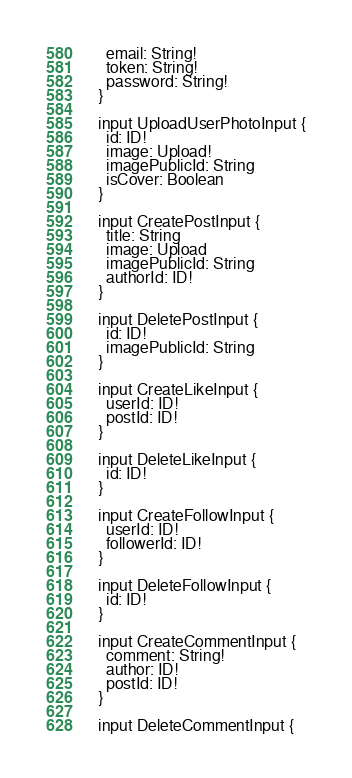Convert code to text. <code><loc_0><loc_0><loc_500><loc_500><_JavaScript_>    email: String!
    token: String!
    password: String!
  }

  input UploadUserPhotoInput {
    id: ID!
    image: Upload!
    imagePublicId: String
    isCover: Boolean
  }

  input CreatePostInput {
    title: String
    image: Upload
    imagePublicId: String
    authorId: ID!
  }

  input DeletePostInput {
    id: ID!
    imagePublicId: String
  }

  input CreateLikeInput {
    userId: ID!
    postId: ID!
  }

  input DeleteLikeInput {
    id: ID!
  }

  input CreateFollowInput {
    userId: ID!
    followerId: ID!
  }

  input DeleteFollowInput {
    id: ID!
  }

  input CreateCommentInput {
    comment: String!
    author: ID!
    postId: ID!
  }

  input DeleteCommentInput {</code> 